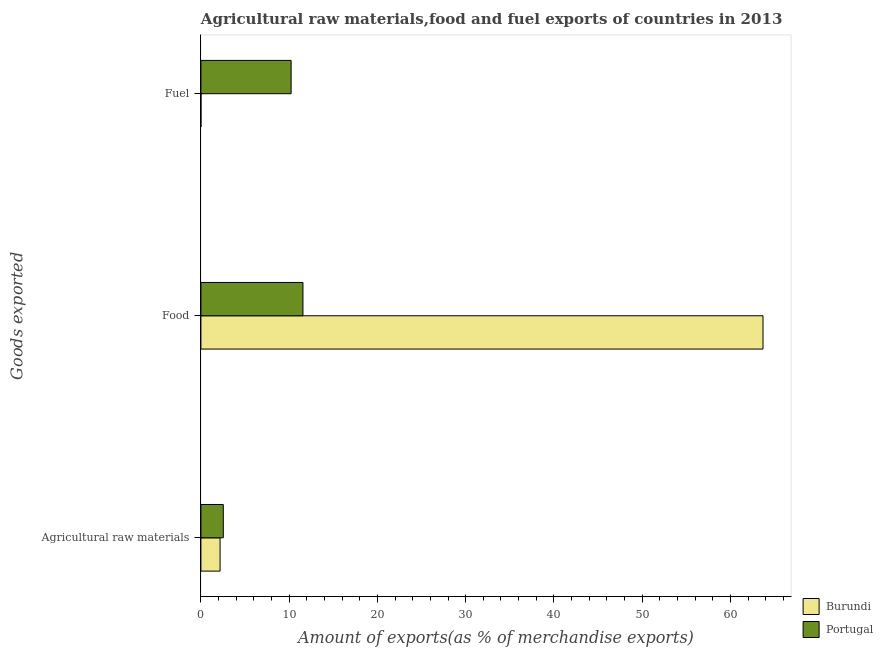How many different coloured bars are there?
Provide a short and direct response. 2. How many groups of bars are there?
Ensure brevity in your answer.  3. How many bars are there on the 1st tick from the top?
Provide a short and direct response. 2. What is the label of the 2nd group of bars from the top?
Offer a terse response. Food. What is the percentage of raw materials exports in Portugal?
Provide a short and direct response. 2.54. Across all countries, what is the maximum percentage of food exports?
Provide a short and direct response. 63.69. Across all countries, what is the minimum percentage of raw materials exports?
Keep it short and to the point. 2.17. In which country was the percentage of food exports maximum?
Your answer should be very brief. Burundi. In which country was the percentage of raw materials exports minimum?
Give a very brief answer. Burundi. What is the total percentage of fuel exports in the graph?
Provide a succinct answer. 10.22. What is the difference between the percentage of raw materials exports in Burundi and that in Portugal?
Offer a terse response. -0.37. What is the difference between the percentage of raw materials exports in Burundi and the percentage of food exports in Portugal?
Offer a terse response. -9.39. What is the average percentage of food exports per country?
Keep it short and to the point. 37.63. What is the difference between the percentage of food exports and percentage of fuel exports in Portugal?
Give a very brief answer. 1.34. In how many countries, is the percentage of raw materials exports greater than 4 %?
Your answer should be compact. 0. What is the ratio of the percentage of raw materials exports in Portugal to that in Burundi?
Give a very brief answer. 1.17. What is the difference between the highest and the second highest percentage of food exports?
Provide a succinct answer. 52.13. What is the difference between the highest and the lowest percentage of raw materials exports?
Keep it short and to the point. 0.37. In how many countries, is the percentage of food exports greater than the average percentage of food exports taken over all countries?
Provide a succinct answer. 1. Is the sum of the percentage of food exports in Burundi and Portugal greater than the maximum percentage of raw materials exports across all countries?
Offer a terse response. Yes. What does the 1st bar from the top in Food represents?
Ensure brevity in your answer.  Portugal. What does the 1st bar from the bottom in Agricultural raw materials represents?
Ensure brevity in your answer.  Burundi. How many bars are there?
Make the answer very short. 6. How many countries are there in the graph?
Give a very brief answer. 2. What is the difference between two consecutive major ticks on the X-axis?
Provide a short and direct response. 10. How many legend labels are there?
Provide a succinct answer. 2. How are the legend labels stacked?
Give a very brief answer. Vertical. What is the title of the graph?
Offer a very short reply. Agricultural raw materials,food and fuel exports of countries in 2013. Does "Lebanon" appear as one of the legend labels in the graph?
Offer a very short reply. No. What is the label or title of the X-axis?
Keep it short and to the point. Amount of exports(as % of merchandise exports). What is the label or title of the Y-axis?
Provide a short and direct response. Goods exported. What is the Amount of exports(as % of merchandise exports) of Burundi in Agricultural raw materials?
Your answer should be very brief. 2.17. What is the Amount of exports(as % of merchandise exports) in Portugal in Agricultural raw materials?
Give a very brief answer. 2.54. What is the Amount of exports(as % of merchandise exports) of Burundi in Food?
Make the answer very short. 63.69. What is the Amount of exports(as % of merchandise exports) of Portugal in Food?
Provide a short and direct response. 11.56. What is the Amount of exports(as % of merchandise exports) in Burundi in Fuel?
Provide a succinct answer. 0. What is the Amount of exports(as % of merchandise exports) of Portugal in Fuel?
Ensure brevity in your answer.  10.22. Across all Goods exported, what is the maximum Amount of exports(as % of merchandise exports) in Burundi?
Your response must be concise. 63.69. Across all Goods exported, what is the maximum Amount of exports(as % of merchandise exports) of Portugal?
Provide a succinct answer. 11.56. Across all Goods exported, what is the minimum Amount of exports(as % of merchandise exports) in Burundi?
Your response must be concise. 0. Across all Goods exported, what is the minimum Amount of exports(as % of merchandise exports) in Portugal?
Your answer should be very brief. 2.54. What is the total Amount of exports(as % of merchandise exports) of Burundi in the graph?
Make the answer very short. 65.86. What is the total Amount of exports(as % of merchandise exports) of Portugal in the graph?
Offer a terse response. 24.32. What is the difference between the Amount of exports(as % of merchandise exports) in Burundi in Agricultural raw materials and that in Food?
Keep it short and to the point. -61.52. What is the difference between the Amount of exports(as % of merchandise exports) of Portugal in Agricultural raw materials and that in Food?
Provide a short and direct response. -9.03. What is the difference between the Amount of exports(as % of merchandise exports) of Burundi in Agricultural raw materials and that in Fuel?
Offer a terse response. 2.17. What is the difference between the Amount of exports(as % of merchandise exports) in Portugal in Agricultural raw materials and that in Fuel?
Your response must be concise. -7.68. What is the difference between the Amount of exports(as % of merchandise exports) of Burundi in Food and that in Fuel?
Keep it short and to the point. 63.69. What is the difference between the Amount of exports(as % of merchandise exports) of Portugal in Food and that in Fuel?
Provide a succinct answer. 1.34. What is the difference between the Amount of exports(as % of merchandise exports) of Burundi in Agricultural raw materials and the Amount of exports(as % of merchandise exports) of Portugal in Food?
Your response must be concise. -9.39. What is the difference between the Amount of exports(as % of merchandise exports) of Burundi in Agricultural raw materials and the Amount of exports(as % of merchandise exports) of Portugal in Fuel?
Your answer should be compact. -8.05. What is the difference between the Amount of exports(as % of merchandise exports) of Burundi in Food and the Amount of exports(as % of merchandise exports) of Portugal in Fuel?
Give a very brief answer. 53.47. What is the average Amount of exports(as % of merchandise exports) of Burundi per Goods exported?
Offer a terse response. 21.95. What is the average Amount of exports(as % of merchandise exports) in Portugal per Goods exported?
Offer a terse response. 8.11. What is the difference between the Amount of exports(as % of merchandise exports) of Burundi and Amount of exports(as % of merchandise exports) of Portugal in Agricultural raw materials?
Offer a very short reply. -0.37. What is the difference between the Amount of exports(as % of merchandise exports) of Burundi and Amount of exports(as % of merchandise exports) of Portugal in Food?
Your response must be concise. 52.13. What is the difference between the Amount of exports(as % of merchandise exports) of Burundi and Amount of exports(as % of merchandise exports) of Portugal in Fuel?
Keep it short and to the point. -10.22. What is the ratio of the Amount of exports(as % of merchandise exports) of Burundi in Agricultural raw materials to that in Food?
Your answer should be compact. 0.03. What is the ratio of the Amount of exports(as % of merchandise exports) of Portugal in Agricultural raw materials to that in Food?
Ensure brevity in your answer.  0.22. What is the ratio of the Amount of exports(as % of merchandise exports) in Burundi in Agricultural raw materials to that in Fuel?
Your response must be concise. 4638.11. What is the ratio of the Amount of exports(as % of merchandise exports) in Portugal in Agricultural raw materials to that in Fuel?
Provide a short and direct response. 0.25. What is the ratio of the Amount of exports(as % of merchandise exports) in Burundi in Food to that in Fuel?
Your answer should be compact. 1.36e+05. What is the ratio of the Amount of exports(as % of merchandise exports) of Portugal in Food to that in Fuel?
Your answer should be very brief. 1.13. What is the difference between the highest and the second highest Amount of exports(as % of merchandise exports) of Burundi?
Keep it short and to the point. 61.52. What is the difference between the highest and the second highest Amount of exports(as % of merchandise exports) of Portugal?
Keep it short and to the point. 1.34. What is the difference between the highest and the lowest Amount of exports(as % of merchandise exports) of Burundi?
Provide a succinct answer. 63.69. What is the difference between the highest and the lowest Amount of exports(as % of merchandise exports) of Portugal?
Offer a terse response. 9.03. 